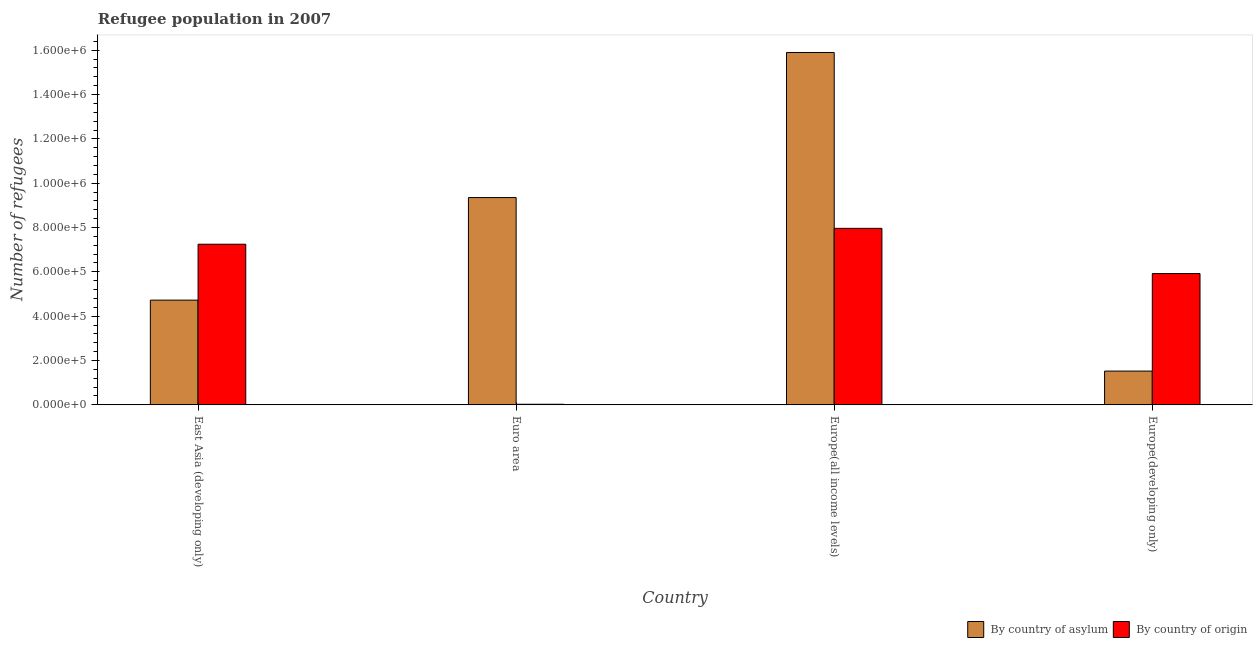How many different coloured bars are there?
Give a very brief answer. 2. How many groups of bars are there?
Ensure brevity in your answer.  4. Are the number of bars per tick equal to the number of legend labels?
Ensure brevity in your answer.  Yes. Are the number of bars on each tick of the X-axis equal?
Offer a terse response. Yes. How many bars are there on the 4th tick from the left?
Offer a terse response. 2. How many bars are there on the 1st tick from the right?
Ensure brevity in your answer.  2. What is the label of the 1st group of bars from the left?
Your response must be concise. East Asia (developing only). What is the number of refugees by country of origin in Euro area?
Make the answer very short. 2429. Across all countries, what is the maximum number of refugees by country of asylum?
Your answer should be compact. 1.59e+06. Across all countries, what is the minimum number of refugees by country of asylum?
Ensure brevity in your answer.  1.52e+05. In which country was the number of refugees by country of origin maximum?
Your answer should be compact. Europe(all income levels). In which country was the number of refugees by country of asylum minimum?
Ensure brevity in your answer.  Europe(developing only). What is the total number of refugees by country of asylum in the graph?
Provide a succinct answer. 3.15e+06. What is the difference between the number of refugees by country of asylum in East Asia (developing only) and that in Europe(developing only)?
Provide a short and direct response. 3.20e+05. What is the difference between the number of refugees by country of asylum in Euro area and the number of refugees by country of origin in Europe(all income levels)?
Keep it short and to the point. 1.39e+05. What is the average number of refugees by country of asylum per country?
Provide a succinct answer. 7.87e+05. What is the difference between the number of refugees by country of origin and number of refugees by country of asylum in East Asia (developing only)?
Keep it short and to the point. 2.52e+05. In how many countries, is the number of refugees by country of asylum greater than 880000 ?
Provide a short and direct response. 2. What is the ratio of the number of refugees by country of origin in East Asia (developing only) to that in Europe(developing only)?
Make the answer very short. 1.22. Is the number of refugees by country of asylum in East Asia (developing only) less than that in Europe(developing only)?
Ensure brevity in your answer.  No. What is the difference between the highest and the second highest number of refugees by country of origin?
Your answer should be very brief. 7.16e+04. What is the difference between the highest and the lowest number of refugees by country of asylum?
Your answer should be compact. 1.44e+06. In how many countries, is the number of refugees by country of asylum greater than the average number of refugees by country of asylum taken over all countries?
Offer a terse response. 2. Is the sum of the number of refugees by country of origin in Euro area and Europe(all income levels) greater than the maximum number of refugees by country of asylum across all countries?
Ensure brevity in your answer.  No. What does the 1st bar from the left in East Asia (developing only) represents?
Offer a very short reply. By country of asylum. What does the 2nd bar from the right in Euro area represents?
Your answer should be compact. By country of asylum. How many bars are there?
Offer a terse response. 8. How many countries are there in the graph?
Provide a succinct answer. 4. How many legend labels are there?
Provide a succinct answer. 2. What is the title of the graph?
Provide a short and direct response. Refugee population in 2007. What is the label or title of the X-axis?
Offer a terse response. Country. What is the label or title of the Y-axis?
Ensure brevity in your answer.  Number of refugees. What is the Number of refugees in By country of asylum in East Asia (developing only)?
Provide a short and direct response. 4.72e+05. What is the Number of refugees of By country of origin in East Asia (developing only)?
Offer a very short reply. 7.25e+05. What is the Number of refugees in By country of asylum in Euro area?
Offer a terse response. 9.35e+05. What is the Number of refugees in By country of origin in Euro area?
Provide a short and direct response. 2429. What is the Number of refugees of By country of asylum in Europe(all income levels)?
Provide a short and direct response. 1.59e+06. What is the Number of refugees of By country of origin in Europe(all income levels)?
Provide a short and direct response. 7.96e+05. What is the Number of refugees of By country of asylum in Europe(developing only)?
Your response must be concise. 1.52e+05. What is the Number of refugees of By country of origin in Europe(developing only)?
Offer a very short reply. 5.92e+05. Across all countries, what is the maximum Number of refugees in By country of asylum?
Your response must be concise. 1.59e+06. Across all countries, what is the maximum Number of refugees in By country of origin?
Give a very brief answer. 7.96e+05. Across all countries, what is the minimum Number of refugees of By country of asylum?
Provide a succinct answer. 1.52e+05. Across all countries, what is the minimum Number of refugees of By country of origin?
Provide a succinct answer. 2429. What is the total Number of refugees in By country of asylum in the graph?
Offer a terse response. 3.15e+06. What is the total Number of refugees in By country of origin in the graph?
Your response must be concise. 2.12e+06. What is the difference between the Number of refugees of By country of asylum in East Asia (developing only) and that in Euro area?
Your answer should be compact. -4.63e+05. What is the difference between the Number of refugees in By country of origin in East Asia (developing only) and that in Euro area?
Your answer should be very brief. 7.22e+05. What is the difference between the Number of refugees of By country of asylum in East Asia (developing only) and that in Europe(all income levels)?
Give a very brief answer. -1.12e+06. What is the difference between the Number of refugees in By country of origin in East Asia (developing only) and that in Europe(all income levels)?
Give a very brief answer. -7.16e+04. What is the difference between the Number of refugees in By country of asylum in East Asia (developing only) and that in Europe(developing only)?
Offer a terse response. 3.20e+05. What is the difference between the Number of refugees in By country of origin in East Asia (developing only) and that in Europe(developing only)?
Make the answer very short. 1.32e+05. What is the difference between the Number of refugees of By country of asylum in Euro area and that in Europe(all income levels)?
Offer a very short reply. -6.55e+05. What is the difference between the Number of refugees of By country of origin in Euro area and that in Europe(all income levels)?
Give a very brief answer. -7.94e+05. What is the difference between the Number of refugees of By country of asylum in Euro area and that in Europe(developing only)?
Make the answer very short. 7.83e+05. What is the difference between the Number of refugees of By country of origin in Euro area and that in Europe(developing only)?
Offer a very short reply. -5.90e+05. What is the difference between the Number of refugees of By country of asylum in Europe(all income levels) and that in Europe(developing only)?
Your answer should be very brief. 1.44e+06. What is the difference between the Number of refugees in By country of origin in Europe(all income levels) and that in Europe(developing only)?
Offer a terse response. 2.04e+05. What is the difference between the Number of refugees of By country of asylum in East Asia (developing only) and the Number of refugees of By country of origin in Euro area?
Make the answer very short. 4.70e+05. What is the difference between the Number of refugees of By country of asylum in East Asia (developing only) and the Number of refugees of By country of origin in Europe(all income levels)?
Your answer should be compact. -3.24e+05. What is the difference between the Number of refugees in By country of asylum in East Asia (developing only) and the Number of refugees in By country of origin in Europe(developing only)?
Offer a terse response. -1.20e+05. What is the difference between the Number of refugees in By country of asylum in Euro area and the Number of refugees in By country of origin in Europe(all income levels)?
Provide a short and direct response. 1.39e+05. What is the difference between the Number of refugees of By country of asylum in Euro area and the Number of refugees of By country of origin in Europe(developing only)?
Your answer should be very brief. 3.43e+05. What is the difference between the Number of refugees of By country of asylum in Europe(all income levels) and the Number of refugees of By country of origin in Europe(developing only)?
Offer a very short reply. 9.98e+05. What is the average Number of refugees in By country of asylum per country?
Your answer should be very brief. 7.87e+05. What is the average Number of refugees of By country of origin per country?
Ensure brevity in your answer.  5.29e+05. What is the difference between the Number of refugees of By country of asylum and Number of refugees of By country of origin in East Asia (developing only)?
Your answer should be very brief. -2.52e+05. What is the difference between the Number of refugees of By country of asylum and Number of refugees of By country of origin in Euro area?
Offer a terse response. 9.33e+05. What is the difference between the Number of refugees of By country of asylum and Number of refugees of By country of origin in Europe(all income levels)?
Offer a terse response. 7.94e+05. What is the difference between the Number of refugees of By country of asylum and Number of refugees of By country of origin in Europe(developing only)?
Provide a succinct answer. -4.40e+05. What is the ratio of the Number of refugees in By country of asylum in East Asia (developing only) to that in Euro area?
Your answer should be very brief. 0.51. What is the ratio of the Number of refugees of By country of origin in East Asia (developing only) to that in Euro area?
Your answer should be very brief. 298.32. What is the ratio of the Number of refugees of By country of asylum in East Asia (developing only) to that in Europe(all income levels)?
Ensure brevity in your answer.  0.3. What is the ratio of the Number of refugees of By country of origin in East Asia (developing only) to that in Europe(all income levels)?
Provide a succinct answer. 0.91. What is the ratio of the Number of refugees in By country of asylum in East Asia (developing only) to that in Europe(developing only)?
Your response must be concise. 3.11. What is the ratio of the Number of refugees in By country of origin in East Asia (developing only) to that in Europe(developing only)?
Provide a short and direct response. 1.22. What is the ratio of the Number of refugees of By country of asylum in Euro area to that in Europe(all income levels)?
Your answer should be very brief. 0.59. What is the ratio of the Number of refugees in By country of origin in Euro area to that in Europe(all income levels)?
Give a very brief answer. 0. What is the ratio of the Number of refugees in By country of asylum in Euro area to that in Europe(developing only)?
Offer a very short reply. 6.15. What is the ratio of the Number of refugees of By country of origin in Euro area to that in Europe(developing only)?
Your response must be concise. 0. What is the ratio of the Number of refugees in By country of asylum in Europe(all income levels) to that in Europe(developing only)?
Your answer should be compact. 10.45. What is the ratio of the Number of refugees of By country of origin in Europe(all income levels) to that in Europe(developing only)?
Offer a very short reply. 1.34. What is the difference between the highest and the second highest Number of refugees in By country of asylum?
Offer a very short reply. 6.55e+05. What is the difference between the highest and the second highest Number of refugees in By country of origin?
Give a very brief answer. 7.16e+04. What is the difference between the highest and the lowest Number of refugees of By country of asylum?
Keep it short and to the point. 1.44e+06. What is the difference between the highest and the lowest Number of refugees in By country of origin?
Offer a terse response. 7.94e+05. 